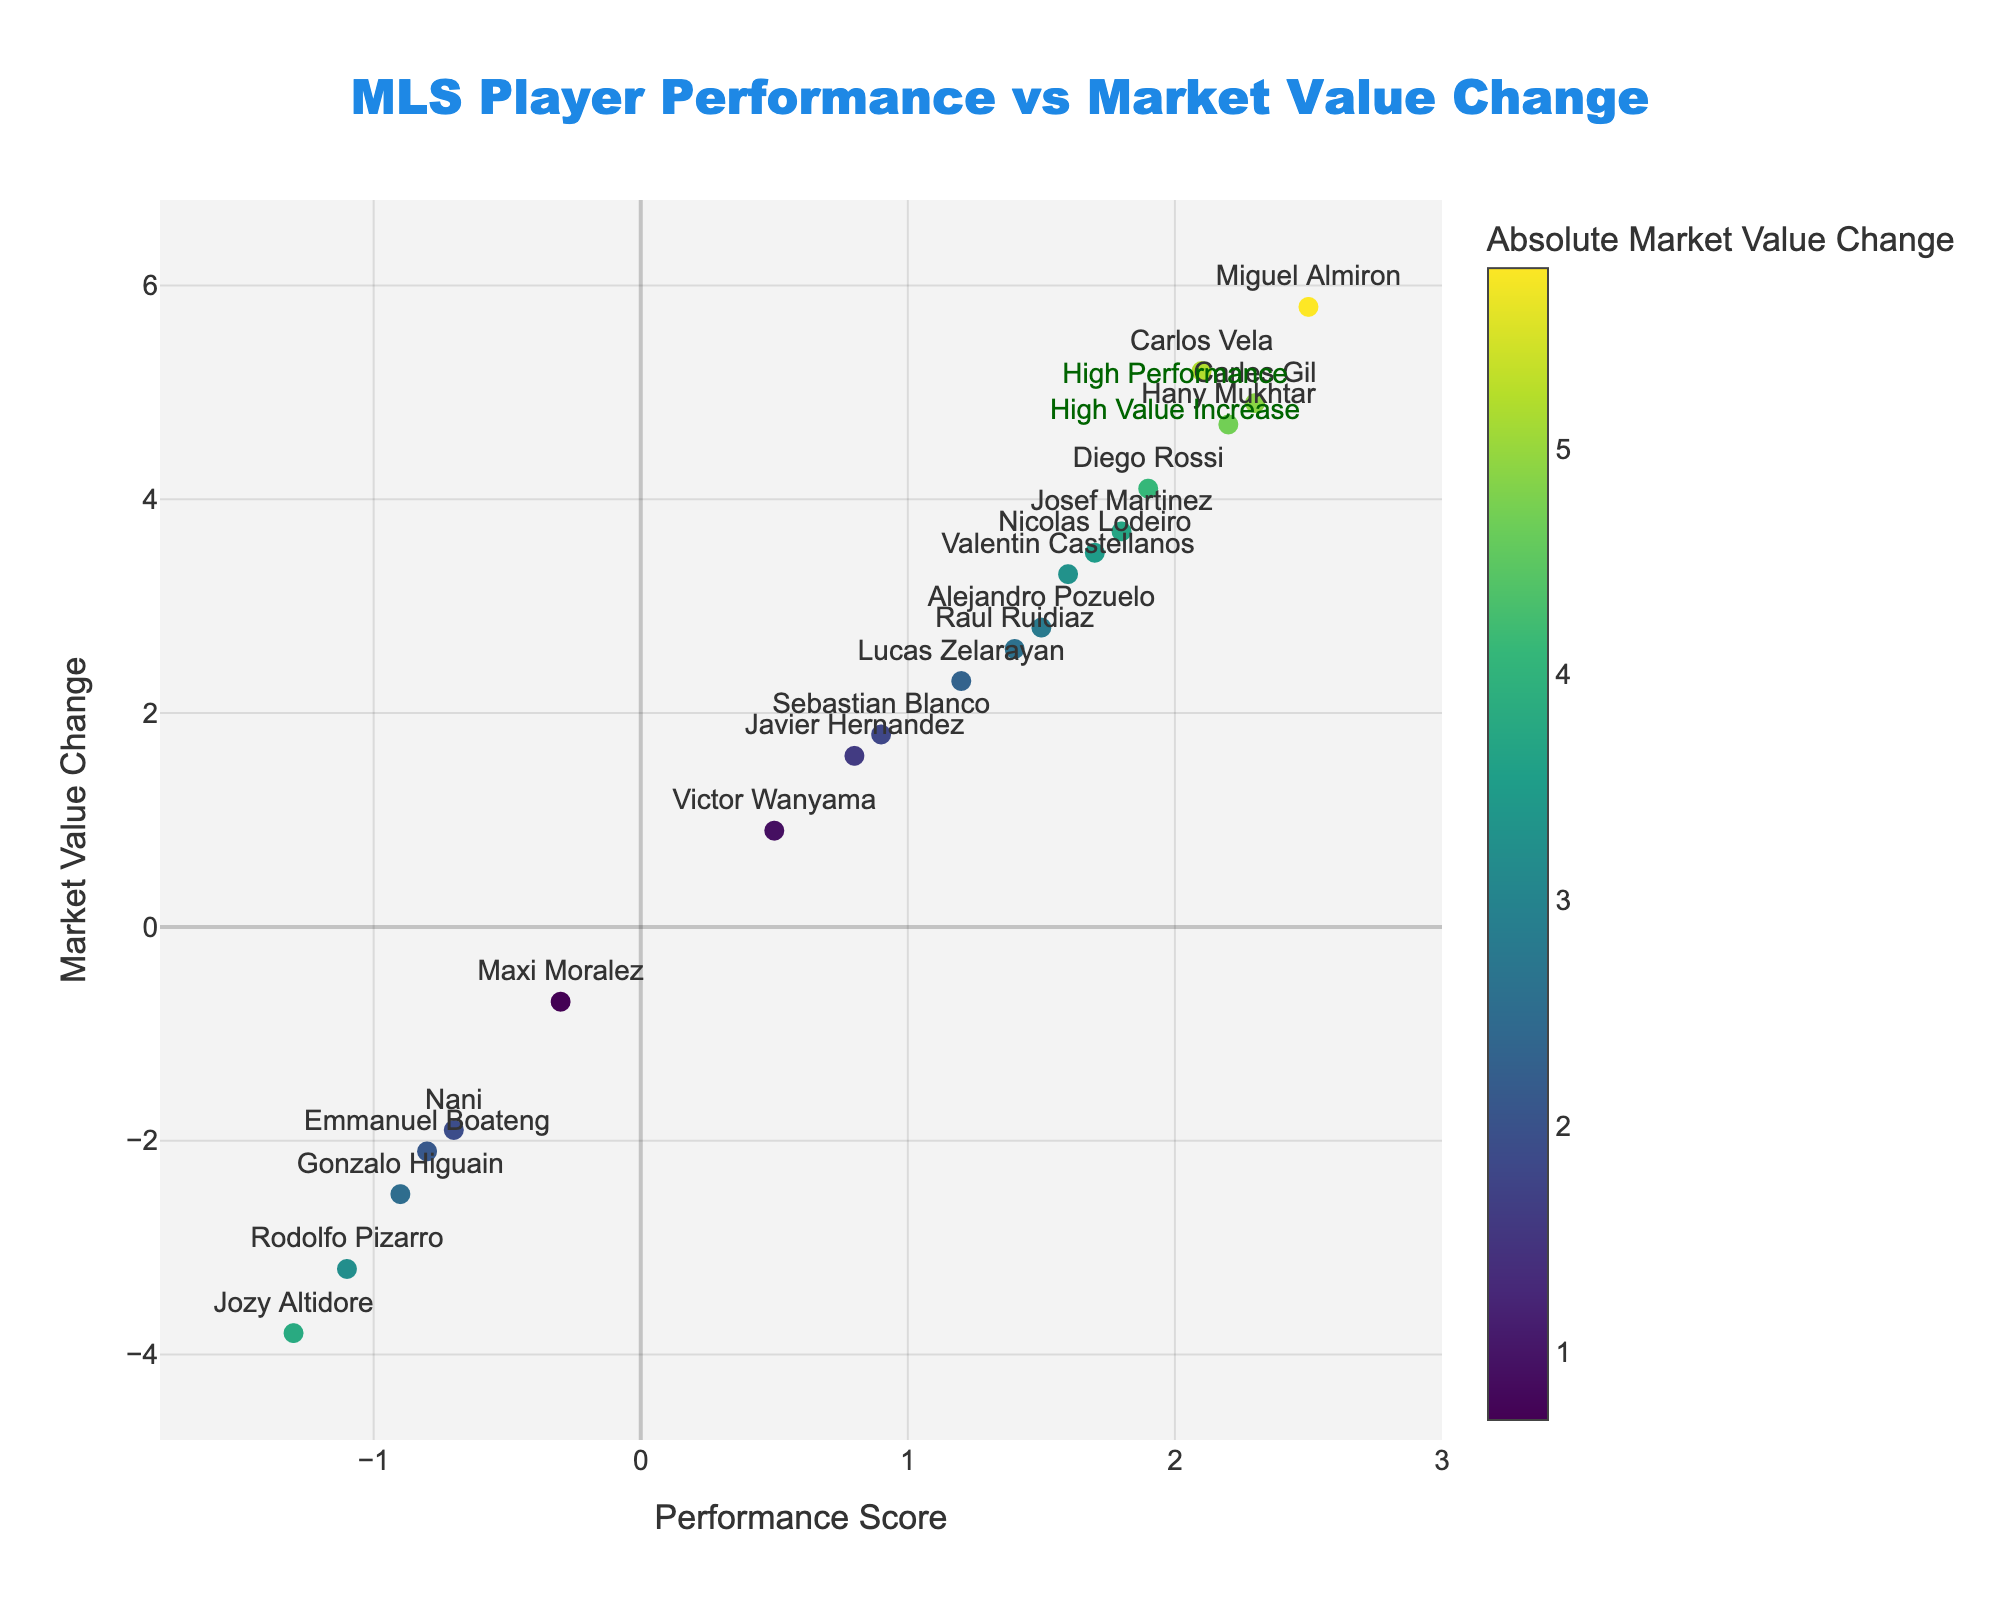Who has the highest market value change? The plot indicates the market value change for different players. The dot with the highest market value change is labeled "Miguel Almiron" with a value of 5.8.
Answer: Miguel Almiron Which player has the lowest performance score but a positive market value change? By examining the plot, the player with the lowest performance score but still having a positive market value change is "Victor Wanyama" with a performance score of 0.5 and a market value change of 0.9.
Answer: Victor Wanyama How many players have a negative market value change? By counting the dots below the zero line on the y-axis, we see there are six players with a negative market value change.
Answer: 6 What is the average market value change of players with a positive performance score? Summing the market value changes of players with positive performance scores (5.2 + 3.7 + 2.8 + 1.6 + 4.9 + 2.3 + 4.1 + 3.5 + 2.6 + 1.8 + 4.7 + 3.3) and then dividing by the number of such players (12) gives the average. The sum is 40.5, so the average is 40.5 / 12 ≈ 3.38.
Answer: 3.38 Which quadrant does the player "Gonzalo Higuain" belong to? "Gonzalo Higuain" has a negative performance score (-0.9) and a negative market value change (-2.5), placing him in the "Low Performance, High Value Decrease" quadrant.
Answer: Low Performance, High Value Decrease Who are the players with the highest performance score and highest market value decrease? There is no player in the "High Performance, High Value Decrease" quadrant, as the dots in the positive performance score section are all above the zero market value change line.
Answer: None How many players have both a positive performance score and a market value change greater than 4.0? By examining the plot, we see the players "Carlos Vela," "Carles Gil," "Diego Rossi," "Miguel Almiron," and "Hany Mukhtar." That's a total of 5 players.
Answer: 5 How many players have a performance score lower than -0.5? Counting the dots on the plot with performance scores lower than -0.5, we see there are three such players.
Answer: 3 What's the total market value change for players with performance scores greater than 2.0? Adding the market value changes for "Carlos Vela" (5.2), "Carles Gil" (4.9), "Miguel Almiron" (5.8), and "Hany Mukhtar" (4.7) results in 5.2 + 4.9 + 5.8 + 4.7 = 20.6.
Answer: 20.6 